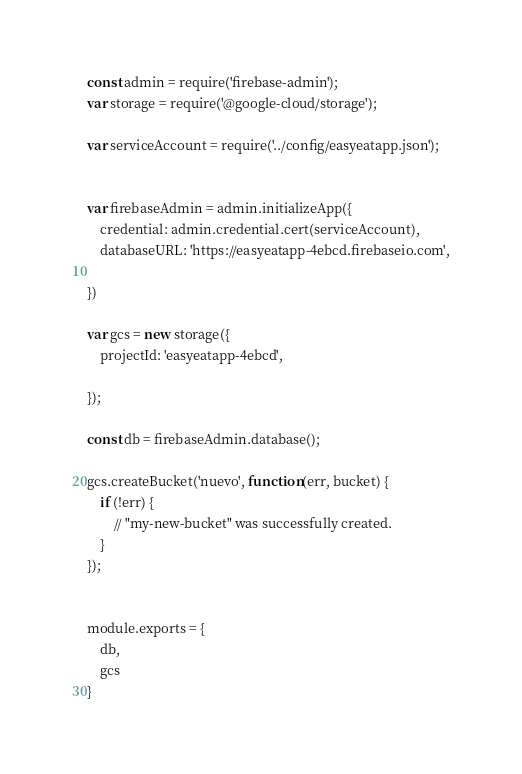<code> <loc_0><loc_0><loc_500><loc_500><_JavaScript_>const admin = require('firebase-admin');
var storage = require('@google-cloud/storage');

var serviceAccount = require('../config/easyeatapp.json');


var firebaseAdmin = admin.initializeApp({
    credential: admin.credential.cert(serviceAccount),
    databaseURL: 'https://easyeatapp-4ebcd.firebaseio.com',

})

var gcs = new storage({
    projectId: 'easyeatapp-4ebcd',

});

const db = firebaseAdmin.database();

gcs.createBucket('nuevo', function(err, bucket) {
    if (!err) {
        // "my-new-bucket" was successfully created.
    }
});


module.exports = {
    db,
    gcs
}</code> 